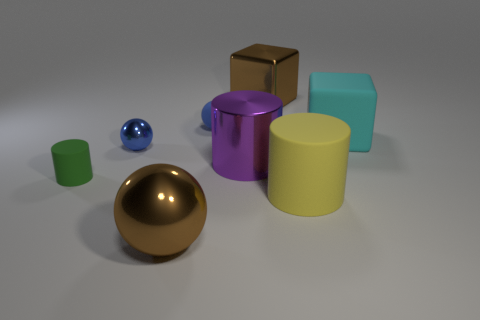There is a matte ball; what number of purple metal cylinders are on the left side of it?
Your answer should be compact. 0. There is another thing that is the same shape as the cyan matte object; what color is it?
Keep it short and to the point. Brown. Do the small blue sphere in front of the small blue matte sphere and the brown thing that is in front of the large brown shiny cube have the same material?
Make the answer very short. Yes. Does the rubber block have the same color as the sphere that is in front of the green matte object?
Your response must be concise. No. What is the shape of the large object that is both right of the purple cylinder and in front of the green object?
Provide a succinct answer. Cylinder. What number of large yellow metal blocks are there?
Provide a succinct answer. 0. There is a object that is the same color as the small matte sphere; what shape is it?
Your response must be concise. Sphere. What size is the green matte thing that is the same shape as the big purple thing?
Give a very brief answer. Small. Do the big brown metal object that is behind the big purple metal thing and the large purple thing have the same shape?
Your response must be concise. No. What is the color of the large thing that is to the right of the yellow rubber cylinder?
Make the answer very short. Cyan. 